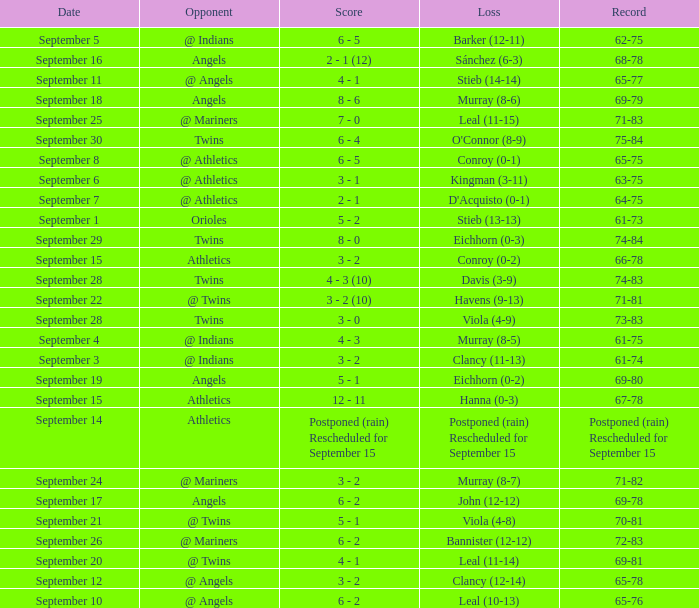Name the loss for record of 71-81 Havens (9-13). 